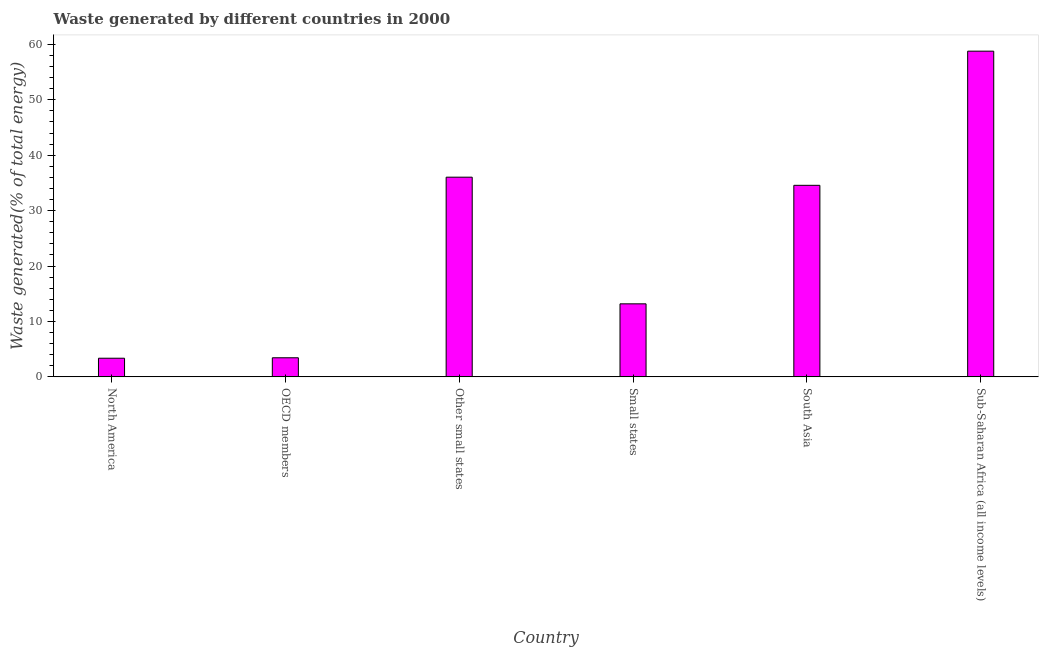Does the graph contain grids?
Offer a terse response. No. What is the title of the graph?
Provide a short and direct response. Waste generated by different countries in 2000. What is the label or title of the X-axis?
Your answer should be very brief. Country. What is the label or title of the Y-axis?
Your answer should be very brief. Waste generated(% of total energy). What is the amount of waste generated in Small states?
Provide a succinct answer. 13.18. Across all countries, what is the maximum amount of waste generated?
Give a very brief answer. 58.77. Across all countries, what is the minimum amount of waste generated?
Offer a terse response. 3.36. In which country was the amount of waste generated maximum?
Offer a terse response. Sub-Saharan Africa (all income levels). In which country was the amount of waste generated minimum?
Offer a very short reply. North America. What is the sum of the amount of waste generated?
Make the answer very short. 149.36. What is the difference between the amount of waste generated in North America and Small states?
Provide a succinct answer. -9.82. What is the average amount of waste generated per country?
Offer a very short reply. 24.89. What is the median amount of waste generated?
Provide a succinct answer. 23.87. What is the ratio of the amount of waste generated in Other small states to that in South Asia?
Make the answer very short. 1.04. Is the amount of waste generated in North America less than that in Sub-Saharan Africa (all income levels)?
Your answer should be compact. Yes. Is the difference between the amount of waste generated in North America and Small states greater than the difference between any two countries?
Your answer should be very brief. No. What is the difference between the highest and the second highest amount of waste generated?
Offer a very short reply. 22.74. What is the difference between the highest and the lowest amount of waste generated?
Keep it short and to the point. 55.41. In how many countries, is the amount of waste generated greater than the average amount of waste generated taken over all countries?
Your response must be concise. 3. How many bars are there?
Offer a very short reply. 6. Are all the bars in the graph horizontal?
Offer a terse response. No. What is the Waste generated(% of total energy) of North America?
Your answer should be compact. 3.36. What is the Waste generated(% of total energy) in OECD members?
Make the answer very short. 3.45. What is the Waste generated(% of total energy) in Other small states?
Give a very brief answer. 36.03. What is the Waste generated(% of total energy) of Small states?
Make the answer very short. 13.18. What is the Waste generated(% of total energy) of South Asia?
Your response must be concise. 34.56. What is the Waste generated(% of total energy) of Sub-Saharan Africa (all income levels)?
Keep it short and to the point. 58.77. What is the difference between the Waste generated(% of total energy) in North America and OECD members?
Your answer should be very brief. -0.08. What is the difference between the Waste generated(% of total energy) in North America and Other small states?
Keep it short and to the point. -32.67. What is the difference between the Waste generated(% of total energy) in North America and Small states?
Offer a terse response. -9.82. What is the difference between the Waste generated(% of total energy) in North America and South Asia?
Offer a terse response. -31.2. What is the difference between the Waste generated(% of total energy) in North America and Sub-Saharan Africa (all income levels)?
Provide a succinct answer. -55.41. What is the difference between the Waste generated(% of total energy) in OECD members and Other small states?
Make the answer very short. -32.59. What is the difference between the Waste generated(% of total energy) in OECD members and Small states?
Keep it short and to the point. -9.73. What is the difference between the Waste generated(% of total energy) in OECD members and South Asia?
Offer a very short reply. -31.12. What is the difference between the Waste generated(% of total energy) in OECD members and Sub-Saharan Africa (all income levels)?
Make the answer very short. -55.32. What is the difference between the Waste generated(% of total energy) in Other small states and Small states?
Offer a terse response. 22.85. What is the difference between the Waste generated(% of total energy) in Other small states and South Asia?
Your answer should be compact. 1.47. What is the difference between the Waste generated(% of total energy) in Other small states and Sub-Saharan Africa (all income levels)?
Offer a very short reply. -22.74. What is the difference between the Waste generated(% of total energy) in Small states and South Asia?
Ensure brevity in your answer.  -21.38. What is the difference between the Waste generated(% of total energy) in Small states and Sub-Saharan Africa (all income levels)?
Make the answer very short. -45.59. What is the difference between the Waste generated(% of total energy) in South Asia and Sub-Saharan Africa (all income levels)?
Provide a short and direct response. -24.21. What is the ratio of the Waste generated(% of total energy) in North America to that in Other small states?
Ensure brevity in your answer.  0.09. What is the ratio of the Waste generated(% of total energy) in North America to that in Small states?
Offer a very short reply. 0.26. What is the ratio of the Waste generated(% of total energy) in North America to that in South Asia?
Your answer should be very brief. 0.1. What is the ratio of the Waste generated(% of total energy) in North America to that in Sub-Saharan Africa (all income levels)?
Offer a terse response. 0.06. What is the ratio of the Waste generated(% of total energy) in OECD members to that in Other small states?
Your response must be concise. 0.1. What is the ratio of the Waste generated(% of total energy) in OECD members to that in Small states?
Provide a succinct answer. 0.26. What is the ratio of the Waste generated(% of total energy) in OECD members to that in Sub-Saharan Africa (all income levels)?
Provide a succinct answer. 0.06. What is the ratio of the Waste generated(% of total energy) in Other small states to that in Small states?
Your response must be concise. 2.73. What is the ratio of the Waste generated(% of total energy) in Other small states to that in South Asia?
Make the answer very short. 1.04. What is the ratio of the Waste generated(% of total energy) in Other small states to that in Sub-Saharan Africa (all income levels)?
Your answer should be very brief. 0.61. What is the ratio of the Waste generated(% of total energy) in Small states to that in South Asia?
Provide a short and direct response. 0.38. What is the ratio of the Waste generated(% of total energy) in Small states to that in Sub-Saharan Africa (all income levels)?
Provide a short and direct response. 0.22. What is the ratio of the Waste generated(% of total energy) in South Asia to that in Sub-Saharan Africa (all income levels)?
Your response must be concise. 0.59. 